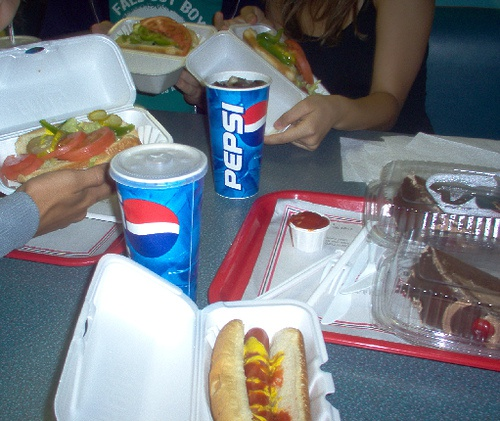Describe the objects in this image and their specific colors. I can see dining table in gray, white, darkgray, and blue tones, people in gray, black, and maroon tones, cup in gray, darkgray, lightblue, blue, and white tones, hot dog in gray, tan, and brown tones, and cake in gray, maroon, and purple tones in this image. 